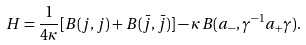Convert formula to latex. <formula><loc_0><loc_0><loc_500><loc_500>H = \frac { 1 } { 4 \kappa } [ B ( j , j ) + B ( \bar { j } , \bar { j } ) ] - \kappa B ( a _ { - } , \gamma ^ { - 1 } a _ { + } \gamma ) .</formula> 